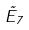<formula> <loc_0><loc_0><loc_500><loc_500>\tilde { E } _ { 7 }</formula> 